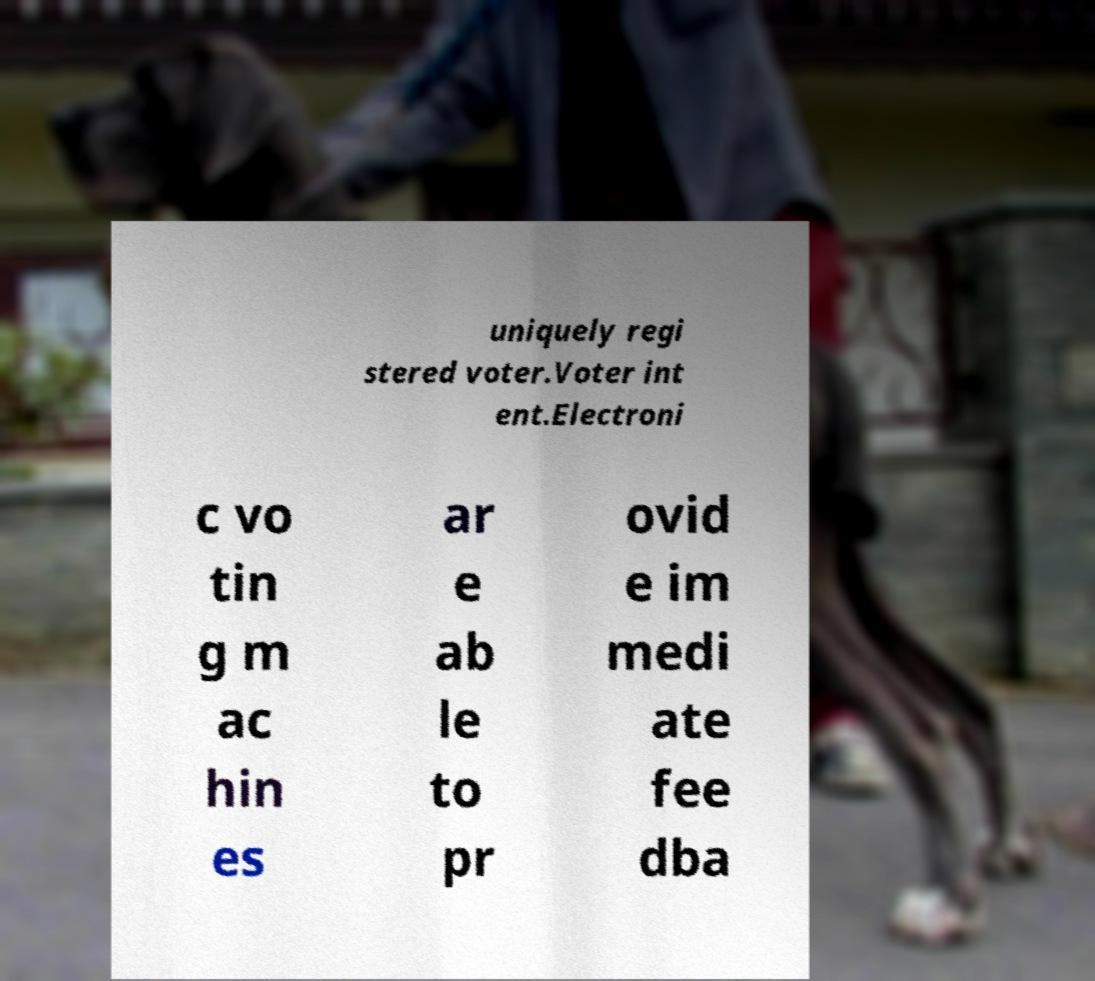What messages or text are displayed in this image? I need them in a readable, typed format. uniquely regi stered voter.Voter int ent.Electroni c vo tin g m ac hin es ar e ab le to pr ovid e im medi ate fee dba 